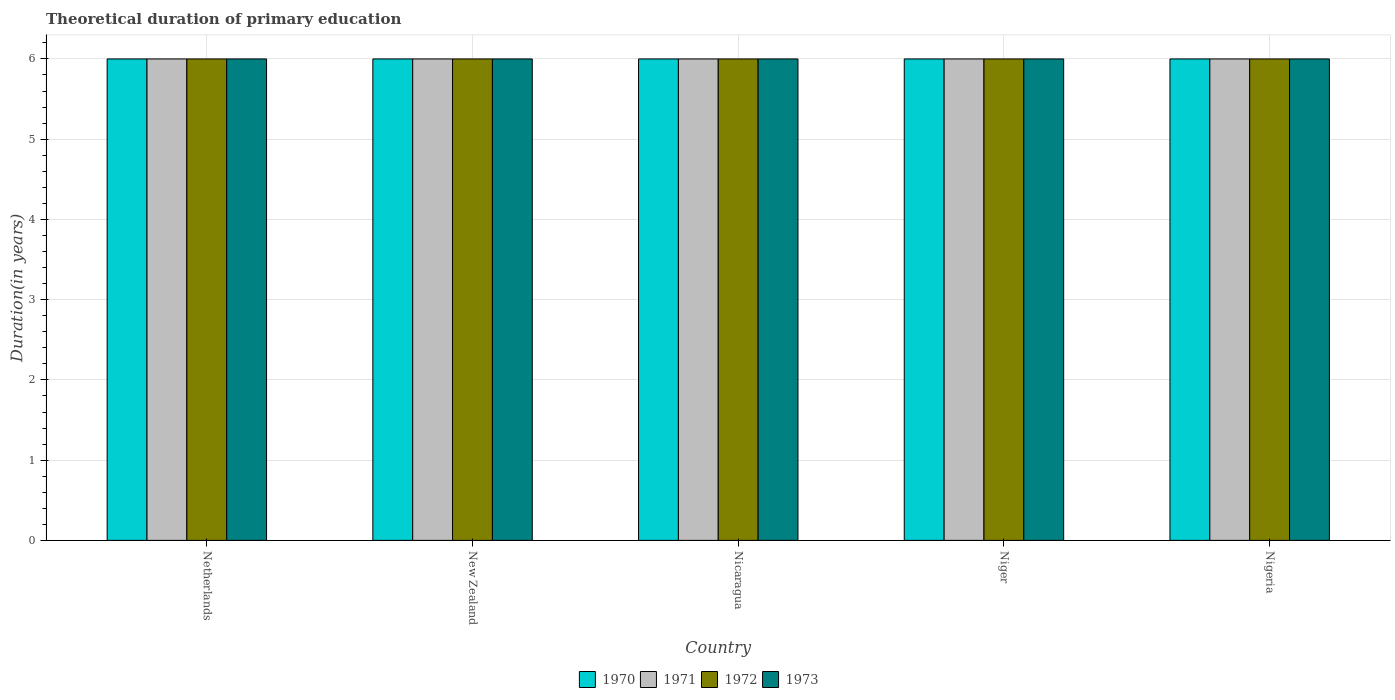Are the number of bars on each tick of the X-axis equal?
Give a very brief answer. Yes. How many bars are there on the 1st tick from the right?
Offer a terse response. 4. What is the label of the 4th group of bars from the left?
Offer a very short reply. Niger. In how many cases, is the number of bars for a given country not equal to the number of legend labels?
Ensure brevity in your answer.  0. Across all countries, what is the maximum total theoretical duration of primary education in 1973?
Your answer should be very brief. 6. In which country was the total theoretical duration of primary education in 1970 maximum?
Keep it short and to the point. Netherlands. In which country was the total theoretical duration of primary education in 1970 minimum?
Your answer should be very brief. Netherlands. What is the difference between the total theoretical duration of primary education in 1971 in New Zealand and that in Nicaragua?
Offer a very short reply. 0. What is the difference between the total theoretical duration of primary education of/in 1970 and total theoretical duration of primary education of/in 1972 in Netherlands?
Give a very brief answer. 0. In how many countries, is the total theoretical duration of primary education in 1970 greater than 1 years?
Your answer should be very brief. 5. What is the ratio of the total theoretical duration of primary education in 1971 in Netherlands to that in Niger?
Your answer should be very brief. 1. Is the total theoretical duration of primary education in 1970 in Netherlands less than that in New Zealand?
Provide a short and direct response. No. Is the difference between the total theoretical duration of primary education in 1970 in Netherlands and Nicaragua greater than the difference between the total theoretical duration of primary education in 1972 in Netherlands and Nicaragua?
Keep it short and to the point. No. What is the difference between the highest and the lowest total theoretical duration of primary education in 1970?
Make the answer very short. 0. Is the sum of the total theoretical duration of primary education in 1970 in New Zealand and Niger greater than the maximum total theoretical duration of primary education in 1972 across all countries?
Provide a succinct answer. Yes. Is it the case that in every country, the sum of the total theoretical duration of primary education in 1972 and total theoretical duration of primary education in 1973 is greater than the sum of total theoretical duration of primary education in 1971 and total theoretical duration of primary education in 1970?
Keep it short and to the point. No. What does the 1st bar from the left in New Zealand represents?
Give a very brief answer. 1970. How many bars are there?
Make the answer very short. 20. Does the graph contain any zero values?
Provide a succinct answer. No. Where does the legend appear in the graph?
Your response must be concise. Bottom center. What is the title of the graph?
Your response must be concise. Theoretical duration of primary education. Does "2005" appear as one of the legend labels in the graph?
Provide a succinct answer. No. What is the label or title of the Y-axis?
Provide a short and direct response. Duration(in years). What is the Duration(in years) of 1970 in Netherlands?
Offer a terse response. 6. What is the Duration(in years) in 1971 in New Zealand?
Offer a terse response. 6. What is the Duration(in years) in 1972 in New Zealand?
Ensure brevity in your answer.  6. What is the Duration(in years) of 1970 in Nicaragua?
Offer a terse response. 6. What is the Duration(in years) in 1971 in Nicaragua?
Ensure brevity in your answer.  6. What is the Duration(in years) of 1972 in Nicaragua?
Your response must be concise. 6. What is the Duration(in years) in 1971 in Niger?
Give a very brief answer. 6. What is the Duration(in years) in 1972 in Niger?
Your answer should be compact. 6. What is the Duration(in years) of 1971 in Nigeria?
Your answer should be compact. 6. What is the Duration(in years) of 1972 in Nigeria?
Your answer should be compact. 6. Across all countries, what is the maximum Duration(in years) of 1970?
Make the answer very short. 6. Across all countries, what is the maximum Duration(in years) of 1971?
Your answer should be compact. 6. Across all countries, what is the minimum Duration(in years) in 1970?
Your answer should be compact. 6. Across all countries, what is the minimum Duration(in years) of 1971?
Offer a terse response. 6. Across all countries, what is the minimum Duration(in years) in 1972?
Provide a short and direct response. 6. What is the total Duration(in years) of 1971 in the graph?
Offer a very short reply. 30. What is the difference between the Duration(in years) of 1970 in Netherlands and that in New Zealand?
Your answer should be compact. 0. What is the difference between the Duration(in years) of 1971 in Netherlands and that in Nicaragua?
Offer a very short reply. 0. What is the difference between the Duration(in years) in 1970 in Netherlands and that in Niger?
Provide a succinct answer. 0. What is the difference between the Duration(in years) of 1972 in Netherlands and that in Niger?
Ensure brevity in your answer.  0. What is the difference between the Duration(in years) in 1973 in Netherlands and that in Niger?
Provide a succinct answer. 0. What is the difference between the Duration(in years) of 1970 in Netherlands and that in Nigeria?
Your answer should be compact. 0. What is the difference between the Duration(in years) of 1971 in Netherlands and that in Nigeria?
Your answer should be very brief. 0. What is the difference between the Duration(in years) in 1972 in Netherlands and that in Nigeria?
Offer a very short reply. 0. What is the difference between the Duration(in years) of 1973 in Netherlands and that in Nigeria?
Give a very brief answer. 0. What is the difference between the Duration(in years) of 1971 in New Zealand and that in Nicaragua?
Your response must be concise. 0. What is the difference between the Duration(in years) in 1973 in New Zealand and that in Nicaragua?
Provide a short and direct response. 0. What is the difference between the Duration(in years) of 1970 in New Zealand and that in Niger?
Your response must be concise. 0. What is the difference between the Duration(in years) in 1971 in New Zealand and that in Niger?
Offer a terse response. 0. What is the difference between the Duration(in years) in 1972 in New Zealand and that in Niger?
Your answer should be compact. 0. What is the difference between the Duration(in years) of 1970 in New Zealand and that in Nigeria?
Ensure brevity in your answer.  0. What is the difference between the Duration(in years) of 1972 in New Zealand and that in Nigeria?
Give a very brief answer. 0. What is the difference between the Duration(in years) in 1973 in New Zealand and that in Nigeria?
Your answer should be compact. 0. What is the difference between the Duration(in years) of 1970 in Nicaragua and that in Niger?
Your answer should be compact. 0. What is the difference between the Duration(in years) in 1971 in Nicaragua and that in Niger?
Your answer should be very brief. 0. What is the difference between the Duration(in years) in 1972 in Nicaragua and that in Niger?
Provide a succinct answer. 0. What is the difference between the Duration(in years) in 1970 in Nicaragua and that in Nigeria?
Offer a very short reply. 0. What is the difference between the Duration(in years) in 1971 in Nicaragua and that in Nigeria?
Make the answer very short. 0. What is the difference between the Duration(in years) of 1973 in Nicaragua and that in Nigeria?
Your answer should be compact. 0. What is the difference between the Duration(in years) of 1970 in Netherlands and the Duration(in years) of 1972 in New Zealand?
Give a very brief answer. 0. What is the difference between the Duration(in years) in 1971 in Netherlands and the Duration(in years) in 1972 in New Zealand?
Your answer should be very brief. 0. What is the difference between the Duration(in years) of 1972 in Netherlands and the Duration(in years) of 1973 in New Zealand?
Make the answer very short. 0. What is the difference between the Duration(in years) in 1970 in Netherlands and the Duration(in years) in 1971 in Nicaragua?
Keep it short and to the point. 0. What is the difference between the Duration(in years) of 1970 in Netherlands and the Duration(in years) of 1972 in Nicaragua?
Your answer should be very brief. 0. What is the difference between the Duration(in years) in 1970 in Netherlands and the Duration(in years) in 1973 in Nicaragua?
Make the answer very short. 0. What is the difference between the Duration(in years) of 1971 in Netherlands and the Duration(in years) of 1972 in Nicaragua?
Give a very brief answer. 0. What is the difference between the Duration(in years) of 1971 in Netherlands and the Duration(in years) of 1973 in Nicaragua?
Give a very brief answer. 0. What is the difference between the Duration(in years) in 1970 in Netherlands and the Duration(in years) in 1971 in Niger?
Make the answer very short. 0. What is the difference between the Duration(in years) of 1970 in Netherlands and the Duration(in years) of 1972 in Niger?
Make the answer very short. 0. What is the difference between the Duration(in years) in 1971 in Netherlands and the Duration(in years) in 1972 in Niger?
Offer a terse response. 0. What is the difference between the Duration(in years) in 1972 in Netherlands and the Duration(in years) in 1973 in Niger?
Your response must be concise. 0. What is the difference between the Duration(in years) in 1970 in Netherlands and the Duration(in years) in 1971 in Nigeria?
Ensure brevity in your answer.  0. What is the difference between the Duration(in years) of 1970 in Netherlands and the Duration(in years) of 1973 in Nigeria?
Offer a terse response. 0. What is the difference between the Duration(in years) in 1971 in Netherlands and the Duration(in years) in 1972 in Nigeria?
Your answer should be very brief. 0. What is the difference between the Duration(in years) in 1971 in Netherlands and the Duration(in years) in 1973 in Nigeria?
Ensure brevity in your answer.  0. What is the difference between the Duration(in years) in 1970 in New Zealand and the Duration(in years) in 1971 in Nicaragua?
Offer a very short reply. 0. What is the difference between the Duration(in years) in 1970 in New Zealand and the Duration(in years) in 1972 in Nicaragua?
Give a very brief answer. 0. What is the difference between the Duration(in years) of 1970 in New Zealand and the Duration(in years) of 1973 in Nicaragua?
Your response must be concise. 0. What is the difference between the Duration(in years) in 1971 in New Zealand and the Duration(in years) in 1973 in Nicaragua?
Keep it short and to the point. 0. What is the difference between the Duration(in years) in 1970 in New Zealand and the Duration(in years) in 1971 in Niger?
Keep it short and to the point. 0. What is the difference between the Duration(in years) in 1970 in New Zealand and the Duration(in years) in 1972 in Niger?
Ensure brevity in your answer.  0. What is the difference between the Duration(in years) in 1971 in New Zealand and the Duration(in years) in 1972 in Niger?
Your response must be concise. 0. What is the difference between the Duration(in years) in 1970 in New Zealand and the Duration(in years) in 1972 in Nigeria?
Provide a succinct answer. 0. What is the difference between the Duration(in years) of 1971 in New Zealand and the Duration(in years) of 1972 in Nigeria?
Offer a very short reply. 0. What is the difference between the Duration(in years) in 1972 in New Zealand and the Duration(in years) in 1973 in Nigeria?
Your response must be concise. 0. What is the difference between the Duration(in years) in 1970 in Nicaragua and the Duration(in years) in 1971 in Niger?
Offer a terse response. 0. What is the difference between the Duration(in years) in 1970 in Nicaragua and the Duration(in years) in 1973 in Niger?
Provide a succinct answer. 0. What is the difference between the Duration(in years) of 1970 in Nicaragua and the Duration(in years) of 1971 in Nigeria?
Offer a terse response. 0. What is the difference between the Duration(in years) in 1970 in Nicaragua and the Duration(in years) in 1973 in Nigeria?
Offer a terse response. 0. What is the difference between the Duration(in years) of 1971 in Nicaragua and the Duration(in years) of 1972 in Nigeria?
Offer a terse response. 0. What is the difference between the Duration(in years) in 1971 in Nicaragua and the Duration(in years) in 1973 in Nigeria?
Your response must be concise. 0. What is the difference between the Duration(in years) in 1970 in Niger and the Duration(in years) in 1972 in Nigeria?
Provide a short and direct response. 0. What is the difference between the Duration(in years) in 1970 in Niger and the Duration(in years) in 1973 in Nigeria?
Your answer should be compact. 0. What is the average Duration(in years) in 1971 per country?
Your answer should be compact. 6. What is the average Duration(in years) in 1972 per country?
Offer a terse response. 6. What is the average Duration(in years) of 1973 per country?
Ensure brevity in your answer.  6. What is the difference between the Duration(in years) of 1970 and Duration(in years) of 1971 in Netherlands?
Ensure brevity in your answer.  0. What is the difference between the Duration(in years) of 1970 and Duration(in years) of 1972 in Netherlands?
Your response must be concise. 0. What is the difference between the Duration(in years) of 1971 and Duration(in years) of 1973 in Netherlands?
Your answer should be compact. 0. What is the difference between the Duration(in years) of 1970 and Duration(in years) of 1972 in New Zealand?
Your answer should be very brief. 0. What is the difference between the Duration(in years) of 1970 and Duration(in years) of 1973 in New Zealand?
Keep it short and to the point. 0. What is the difference between the Duration(in years) of 1971 and Duration(in years) of 1972 in New Zealand?
Give a very brief answer. 0. What is the difference between the Duration(in years) of 1971 and Duration(in years) of 1973 in New Zealand?
Give a very brief answer. 0. What is the difference between the Duration(in years) in 1972 and Duration(in years) in 1973 in New Zealand?
Your answer should be compact. 0. What is the difference between the Duration(in years) of 1970 and Duration(in years) of 1973 in Nicaragua?
Your answer should be very brief. 0. What is the difference between the Duration(in years) in 1971 and Duration(in years) in 1973 in Nicaragua?
Your response must be concise. 0. What is the difference between the Duration(in years) of 1972 and Duration(in years) of 1973 in Nicaragua?
Give a very brief answer. 0. What is the difference between the Duration(in years) of 1970 and Duration(in years) of 1973 in Niger?
Ensure brevity in your answer.  0. What is the difference between the Duration(in years) of 1970 and Duration(in years) of 1972 in Nigeria?
Make the answer very short. 0. What is the difference between the Duration(in years) in 1971 and Duration(in years) in 1972 in Nigeria?
Give a very brief answer. 0. What is the ratio of the Duration(in years) in 1970 in Netherlands to that in New Zealand?
Provide a succinct answer. 1. What is the ratio of the Duration(in years) of 1971 in Netherlands to that in New Zealand?
Your response must be concise. 1. What is the ratio of the Duration(in years) of 1972 in Netherlands to that in New Zealand?
Offer a terse response. 1. What is the ratio of the Duration(in years) of 1971 in Netherlands to that in Niger?
Make the answer very short. 1. What is the ratio of the Duration(in years) of 1973 in Netherlands to that in Niger?
Offer a terse response. 1. What is the ratio of the Duration(in years) of 1970 in Netherlands to that in Nigeria?
Your answer should be very brief. 1. What is the ratio of the Duration(in years) in 1971 in Netherlands to that in Nigeria?
Keep it short and to the point. 1. What is the ratio of the Duration(in years) in 1972 in Netherlands to that in Nigeria?
Your answer should be compact. 1. What is the ratio of the Duration(in years) in 1973 in Netherlands to that in Nigeria?
Your answer should be compact. 1. What is the ratio of the Duration(in years) in 1970 in New Zealand to that in Nicaragua?
Give a very brief answer. 1. What is the ratio of the Duration(in years) of 1972 in New Zealand to that in Nicaragua?
Offer a terse response. 1. What is the ratio of the Duration(in years) of 1973 in New Zealand to that in Nicaragua?
Provide a short and direct response. 1. What is the ratio of the Duration(in years) of 1971 in New Zealand to that in Niger?
Provide a succinct answer. 1. What is the ratio of the Duration(in years) in 1972 in New Zealand to that in Niger?
Keep it short and to the point. 1. What is the ratio of the Duration(in years) in 1973 in New Zealand to that in Niger?
Provide a short and direct response. 1. What is the ratio of the Duration(in years) in 1970 in New Zealand to that in Nigeria?
Provide a succinct answer. 1. What is the ratio of the Duration(in years) of 1971 in Nicaragua to that in Niger?
Ensure brevity in your answer.  1. What is the ratio of the Duration(in years) in 1970 in Nicaragua to that in Nigeria?
Make the answer very short. 1. What is the ratio of the Duration(in years) of 1973 in Nicaragua to that in Nigeria?
Your response must be concise. 1. What is the ratio of the Duration(in years) in 1970 in Niger to that in Nigeria?
Offer a very short reply. 1. What is the ratio of the Duration(in years) of 1973 in Niger to that in Nigeria?
Offer a terse response. 1. What is the difference between the highest and the second highest Duration(in years) in 1970?
Your answer should be compact. 0. What is the difference between the highest and the lowest Duration(in years) in 1973?
Provide a succinct answer. 0. 